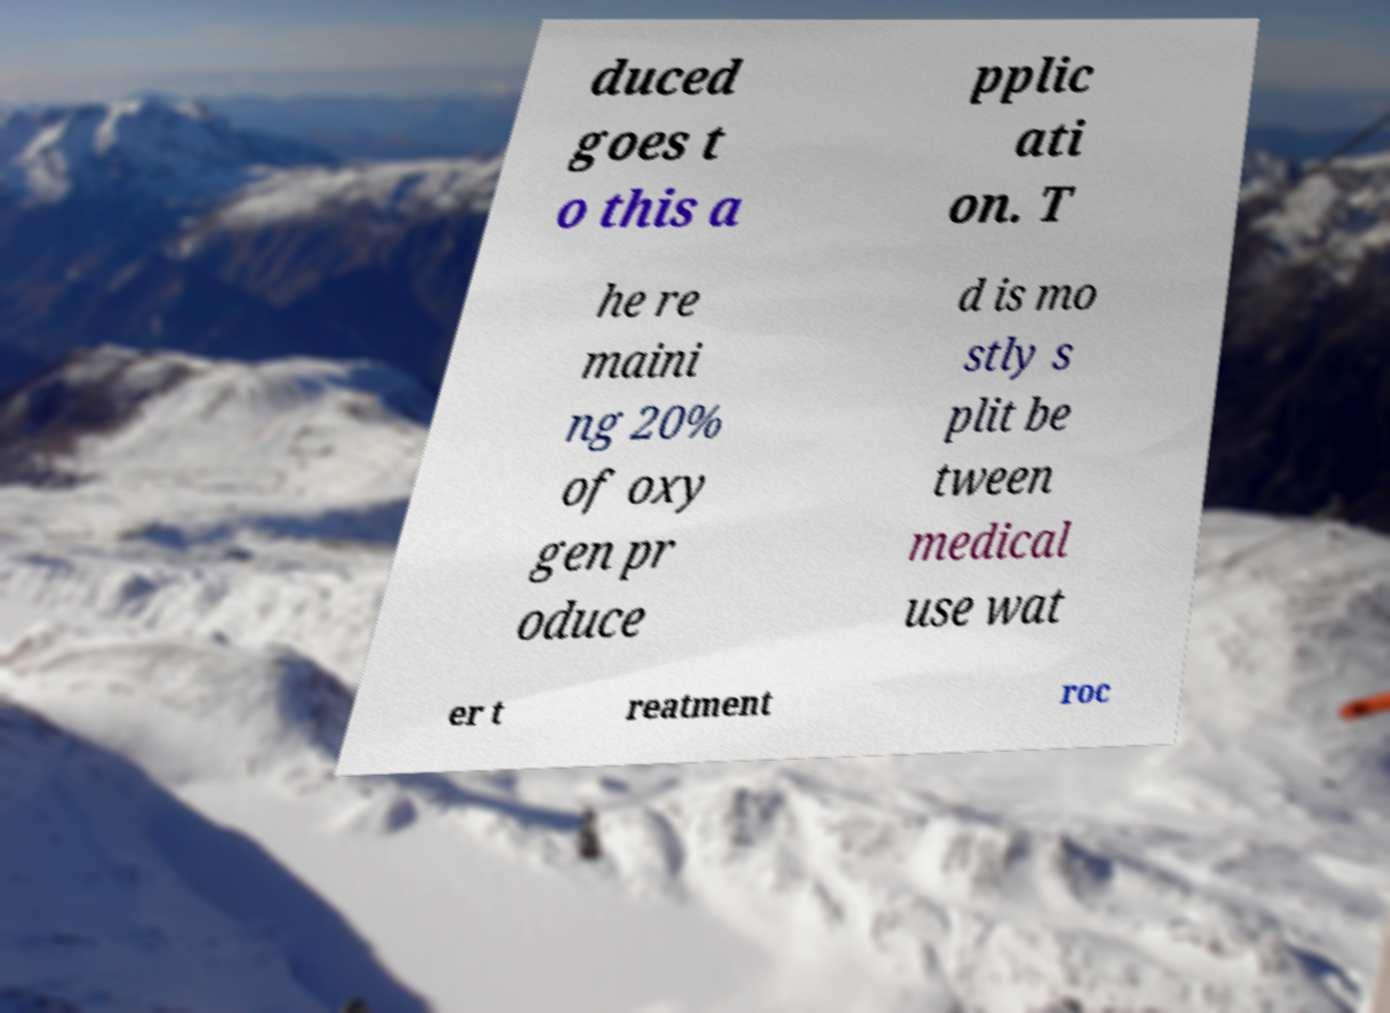What messages or text are displayed in this image? I need them in a readable, typed format. duced goes t o this a pplic ati on. T he re maini ng 20% of oxy gen pr oduce d is mo stly s plit be tween medical use wat er t reatment roc 